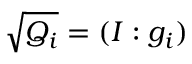<formula> <loc_0><loc_0><loc_500><loc_500>{ \sqrt { Q _ { i } } } = ( I \colon g _ { i } )</formula> 